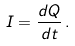Convert formula to latex. <formula><loc_0><loc_0><loc_500><loc_500>I = { \frac { d Q } { d t } } \, .</formula> 